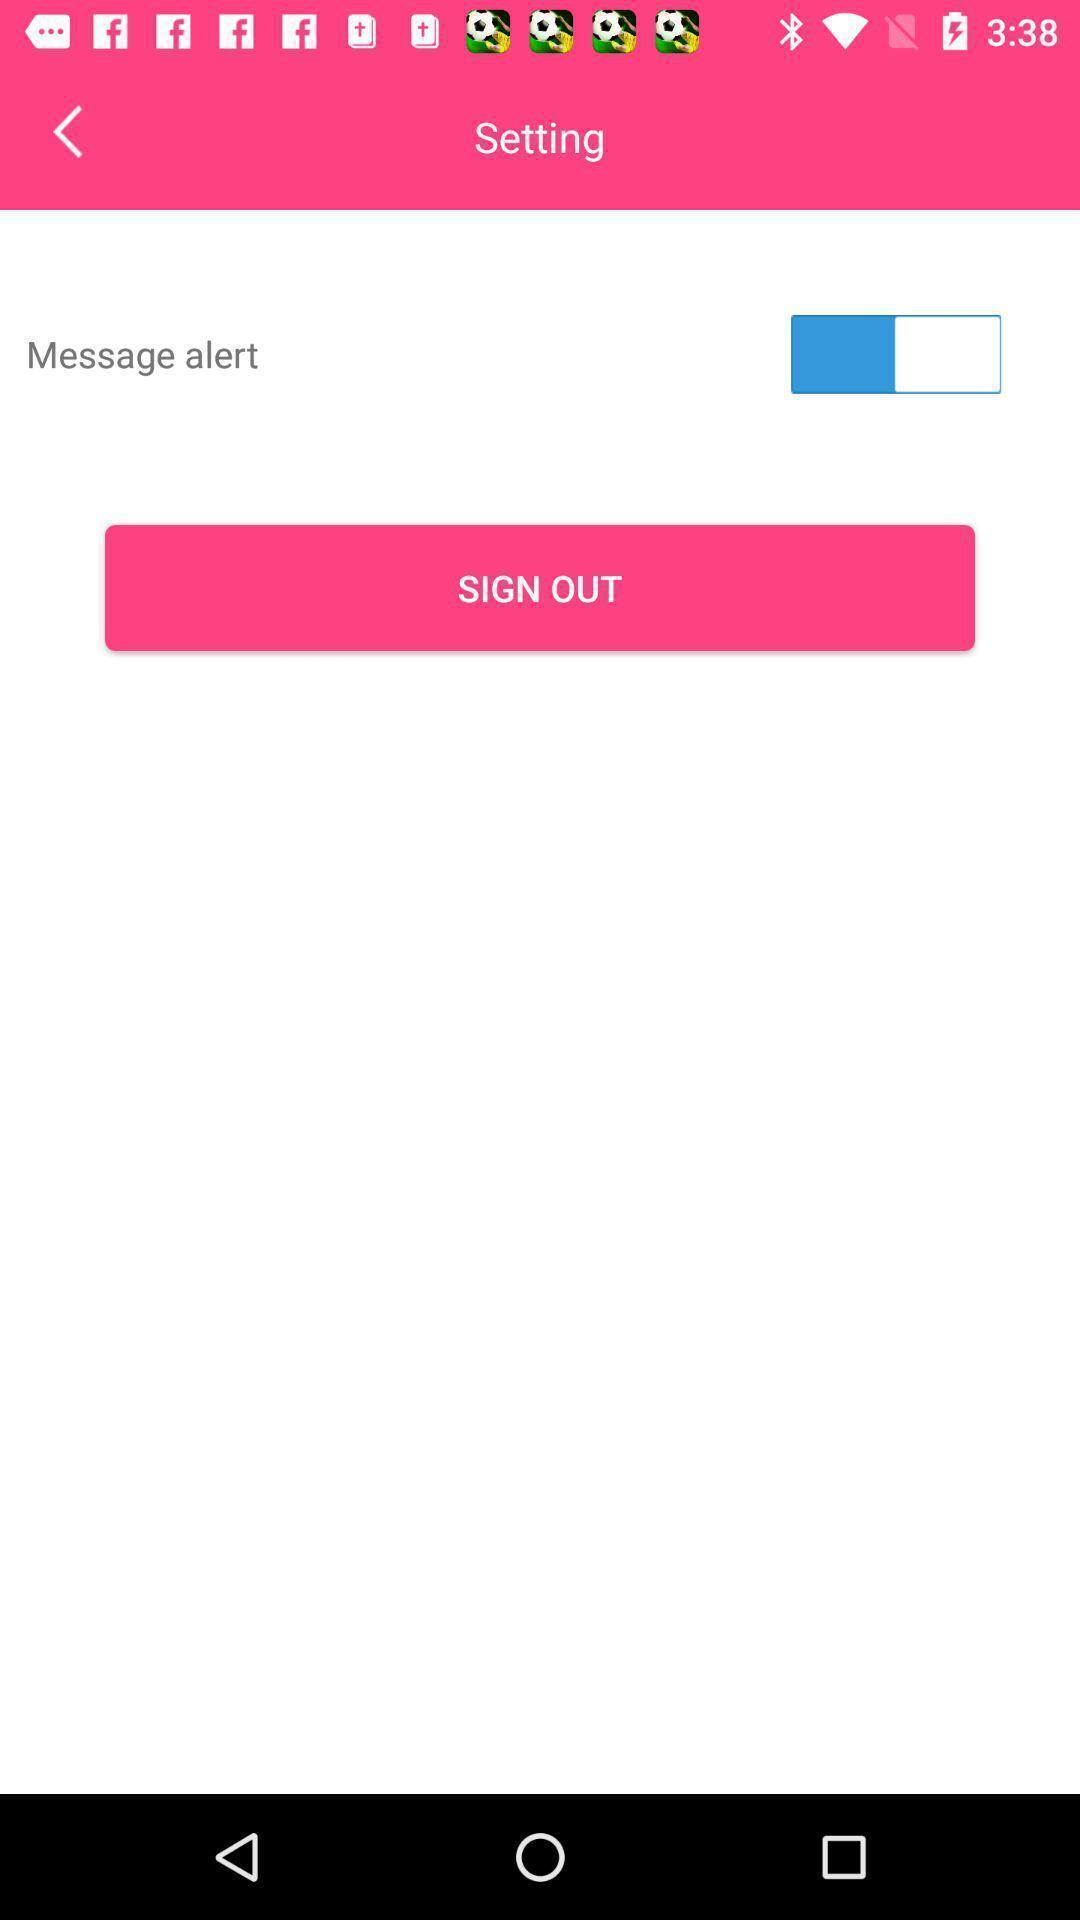Give me a narrative description of this picture. Screen showing setting page. 